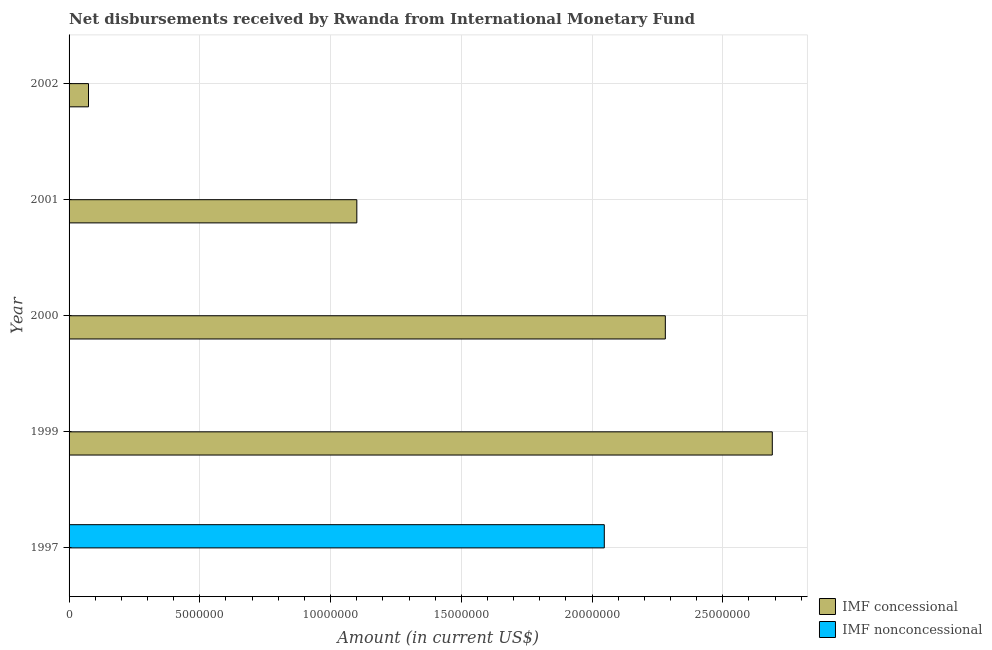Are the number of bars per tick equal to the number of legend labels?
Your response must be concise. No. What is the label of the 2nd group of bars from the top?
Your response must be concise. 2001. In how many cases, is the number of bars for a given year not equal to the number of legend labels?
Provide a succinct answer. 5. Across all years, what is the maximum net concessional disbursements from imf?
Your response must be concise. 2.69e+07. In which year was the net non concessional disbursements from imf maximum?
Provide a short and direct response. 1997. What is the total net non concessional disbursements from imf in the graph?
Give a very brief answer. 2.05e+07. What is the difference between the net concessional disbursements from imf in 1999 and that in 2002?
Give a very brief answer. 2.62e+07. What is the average net non concessional disbursements from imf per year?
Offer a very short reply. 4.09e+06. What is the ratio of the net concessional disbursements from imf in 1999 to that in 2002?
Provide a short and direct response. 36.2. What is the difference between the highest and the second highest net concessional disbursements from imf?
Offer a very short reply. 4.09e+06. What is the difference between the highest and the lowest net concessional disbursements from imf?
Offer a terse response. 2.69e+07. Is the sum of the net concessional disbursements from imf in 2000 and 2001 greater than the maximum net non concessional disbursements from imf across all years?
Your answer should be compact. Yes. How many years are there in the graph?
Ensure brevity in your answer.  5. What is the difference between two consecutive major ticks on the X-axis?
Your answer should be compact. 5.00e+06. Are the values on the major ticks of X-axis written in scientific E-notation?
Your answer should be very brief. No. Does the graph contain any zero values?
Provide a succinct answer. Yes. Does the graph contain grids?
Your answer should be compact. Yes. How many legend labels are there?
Make the answer very short. 2. What is the title of the graph?
Your answer should be compact. Net disbursements received by Rwanda from International Monetary Fund. Does "Non-solid fuel" appear as one of the legend labels in the graph?
Provide a succinct answer. No. What is the label or title of the X-axis?
Offer a terse response. Amount (in current US$). What is the label or title of the Y-axis?
Keep it short and to the point. Year. What is the Amount (in current US$) of IMF concessional in 1997?
Ensure brevity in your answer.  0. What is the Amount (in current US$) in IMF nonconcessional in 1997?
Keep it short and to the point. 2.05e+07. What is the Amount (in current US$) in IMF concessional in 1999?
Make the answer very short. 2.69e+07. What is the Amount (in current US$) in IMF nonconcessional in 1999?
Your answer should be very brief. 0. What is the Amount (in current US$) of IMF concessional in 2000?
Provide a succinct answer. 2.28e+07. What is the Amount (in current US$) of IMF concessional in 2001?
Make the answer very short. 1.10e+07. What is the Amount (in current US$) in IMF concessional in 2002?
Provide a succinct answer. 7.43e+05. What is the Amount (in current US$) in IMF nonconcessional in 2002?
Ensure brevity in your answer.  0. Across all years, what is the maximum Amount (in current US$) in IMF concessional?
Provide a succinct answer. 2.69e+07. Across all years, what is the maximum Amount (in current US$) of IMF nonconcessional?
Give a very brief answer. 2.05e+07. Across all years, what is the minimum Amount (in current US$) of IMF nonconcessional?
Your response must be concise. 0. What is the total Amount (in current US$) of IMF concessional in the graph?
Your answer should be very brief. 6.14e+07. What is the total Amount (in current US$) in IMF nonconcessional in the graph?
Give a very brief answer. 2.05e+07. What is the difference between the Amount (in current US$) in IMF concessional in 1999 and that in 2000?
Your answer should be compact. 4.09e+06. What is the difference between the Amount (in current US$) in IMF concessional in 1999 and that in 2001?
Keep it short and to the point. 1.59e+07. What is the difference between the Amount (in current US$) in IMF concessional in 1999 and that in 2002?
Offer a terse response. 2.62e+07. What is the difference between the Amount (in current US$) in IMF concessional in 2000 and that in 2001?
Your response must be concise. 1.18e+07. What is the difference between the Amount (in current US$) in IMF concessional in 2000 and that in 2002?
Your answer should be compact. 2.21e+07. What is the difference between the Amount (in current US$) in IMF concessional in 2001 and that in 2002?
Ensure brevity in your answer.  1.03e+07. What is the average Amount (in current US$) of IMF concessional per year?
Your answer should be compact. 1.23e+07. What is the average Amount (in current US$) in IMF nonconcessional per year?
Provide a succinct answer. 4.09e+06. What is the ratio of the Amount (in current US$) of IMF concessional in 1999 to that in 2000?
Your answer should be very brief. 1.18. What is the ratio of the Amount (in current US$) in IMF concessional in 1999 to that in 2001?
Your answer should be compact. 2.44. What is the ratio of the Amount (in current US$) in IMF concessional in 1999 to that in 2002?
Offer a terse response. 36.2. What is the ratio of the Amount (in current US$) of IMF concessional in 2000 to that in 2001?
Make the answer very short. 2.07. What is the ratio of the Amount (in current US$) in IMF concessional in 2000 to that in 2002?
Your answer should be compact. 30.69. What is the ratio of the Amount (in current US$) of IMF concessional in 2001 to that in 2002?
Offer a very short reply. 14.81. What is the difference between the highest and the second highest Amount (in current US$) of IMF concessional?
Your answer should be very brief. 4.09e+06. What is the difference between the highest and the lowest Amount (in current US$) of IMF concessional?
Provide a succinct answer. 2.69e+07. What is the difference between the highest and the lowest Amount (in current US$) of IMF nonconcessional?
Your response must be concise. 2.05e+07. 